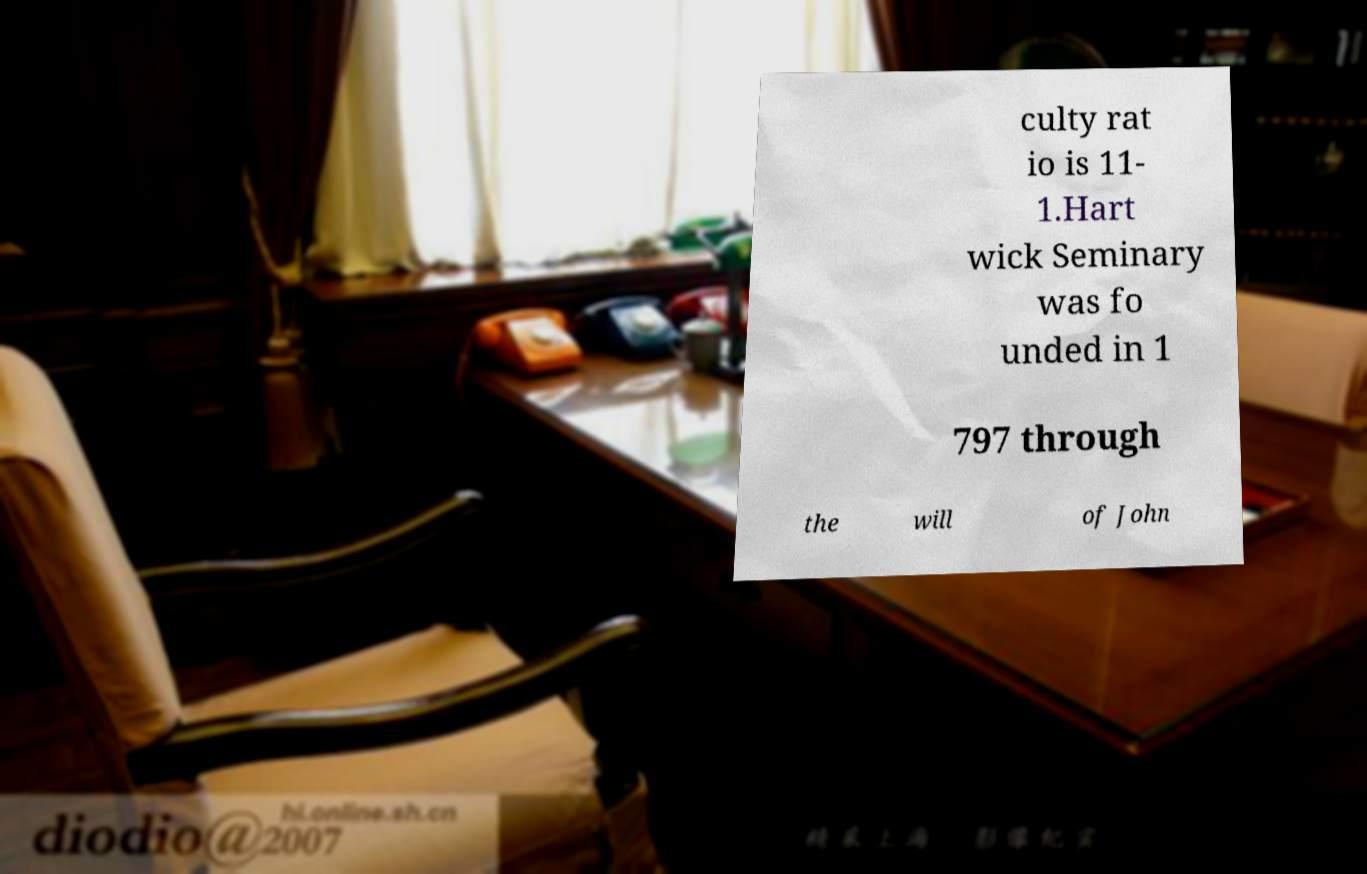What messages or text are displayed in this image? I need them in a readable, typed format. culty rat io is 11- 1.Hart wick Seminary was fo unded in 1 797 through the will of John 